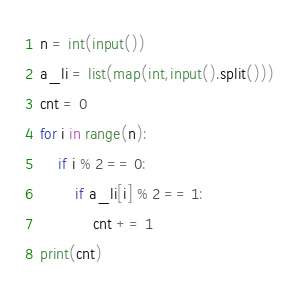Convert code to text. <code><loc_0><loc_0><loc_500><loc_500><_Python_>n = int(input())
a_li = list(map(int,input().split()))
cnt = 0
for i in range(n):
    if i % 2 == 0:
        if a_li[i] % 2 == 1:
            cnt += 1
print(cnt)</code> 